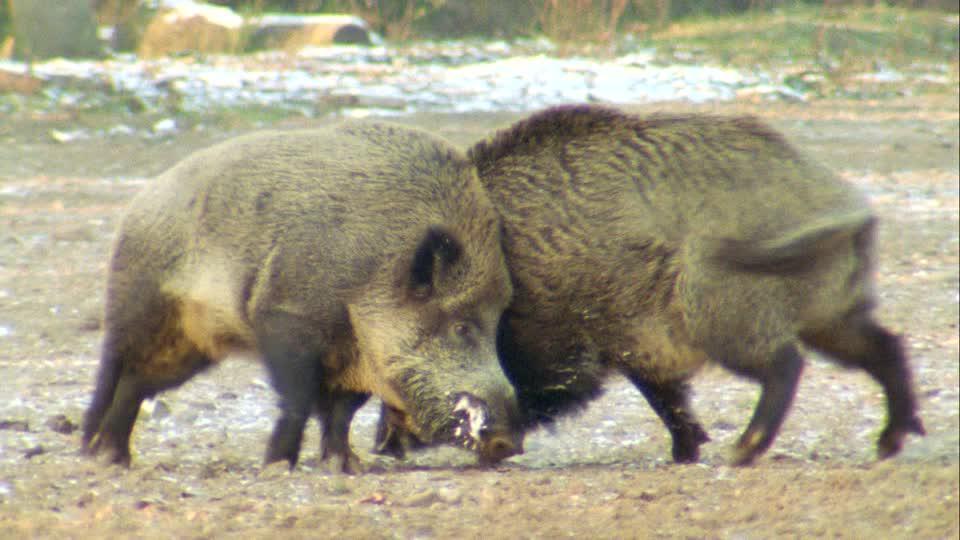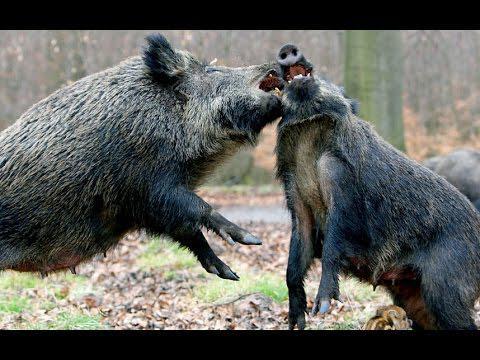The first image is the image on the left, the second image is the image on the right. Analyze the images presented: Is the assertion "The left and right image contains the same number of fighting hogs." valid? Answer yes or no. Yes. The first image is the image on the left, the second image is the image on the right. Assess this claim about the two images: "Each image shows two hogs in a face-to-face confrontation, and in one image the hogs have their front feet off the ground.". Correct or not? Answer yes or no. Yes. 